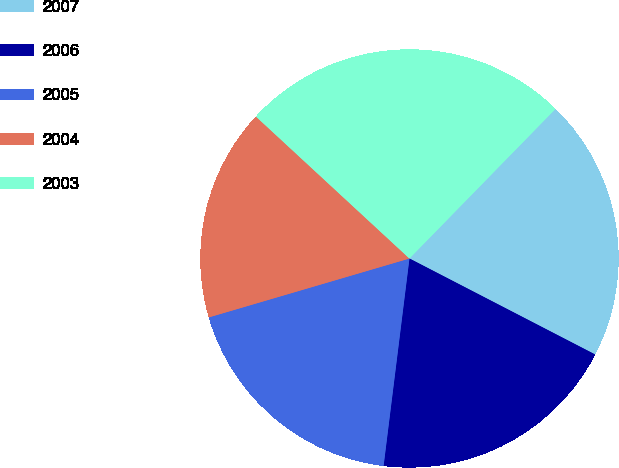<chart> <loc_0><loc_0><loc_500><loc_500><pie_chart><fcel>2007<fcel>2006<fcel>2005<fcel>2004<fcel>2003<nl><fcel>20.28%<fcel>19.38%<fcel>18.48%<fcel>16.42%<fcel>25.43%<nl></chart> 